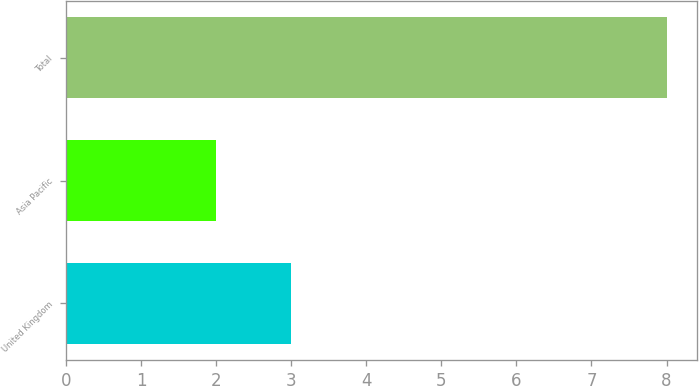Convert chart to OTSL. <chart><loc_0><loc_0><loc_500><loc_500><bar_chart><fcel>United Kingdom<fcel>Asia Pacific<fcel>Total<nl><fcel>3<fcel>2<fcel>8<nl></chart> 